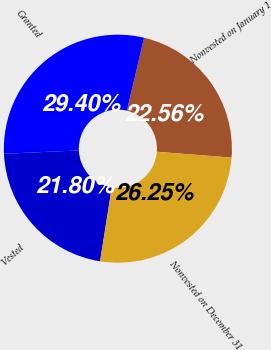<chart> <loc_0><loc_0><loc_500><loc_500><pie_chart><fcel>Nonvested on January 1<fcel>Granted<fcel>Vested<fcel>Nonvested on December 31<nl><fcel>22.56%<fcel>29.4%<fcel>21.8%<fcel>26.25%<nl></chart> 